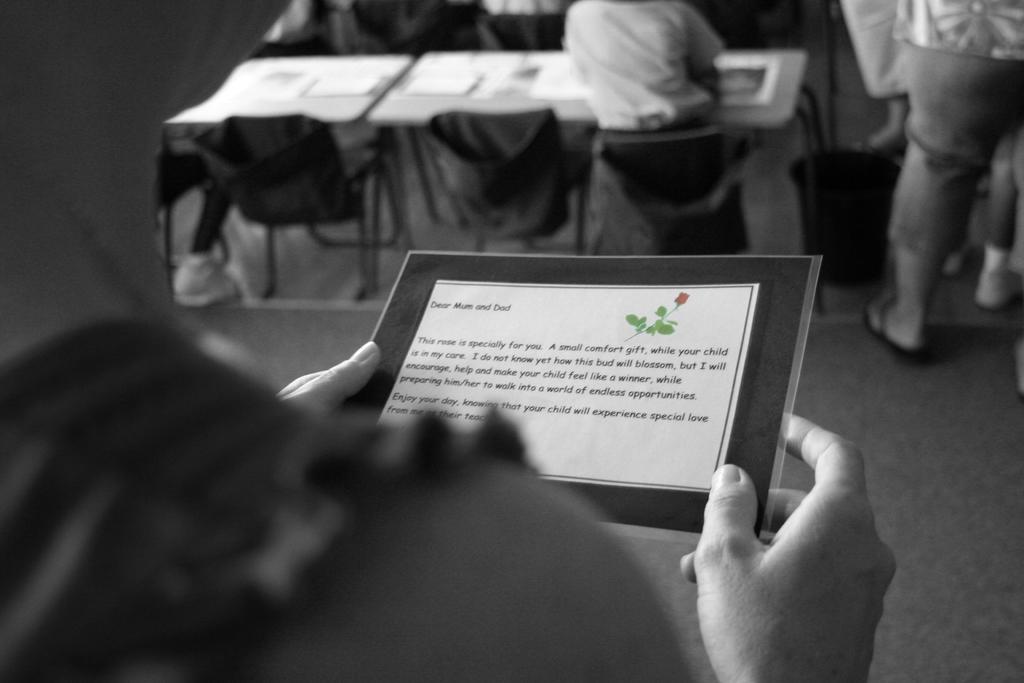How would you summarize this image in a sentence or two? In this image, we can see a person holding a paper, we can see a table, there are some chairs, we can see a person sitting on the chair, we can see a person standing. 